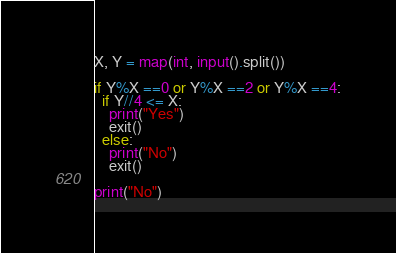Convert code to text. <code><loc_0><loc_0><loc_500><loc_500><_Python_>X, Y = map(int, input().split())

if Y%X ==0 or Y%X ==2 or Y%X ==4:
  if Y//4 <= X:
    print("Yes")
    exit()
  else:
    print("No")
    exit()

print("No")</code> 